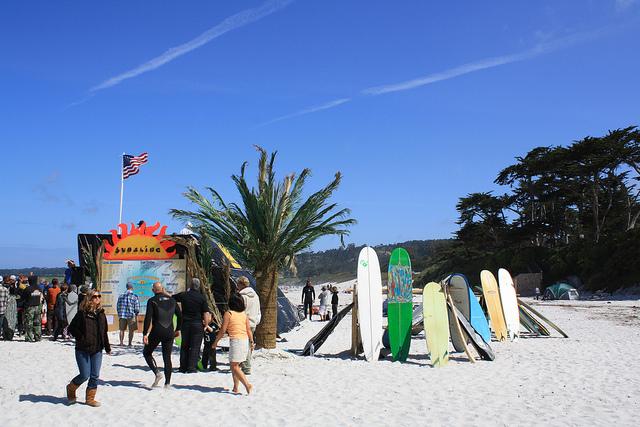Was this picture taken in the summer?
Answer briefly. Yes. What does sand feel like?
Give a very brief answer. Soft. Is the day windy?
Quick response, please. Yes. Is there water nearby?
Keep it brief. Yes. 